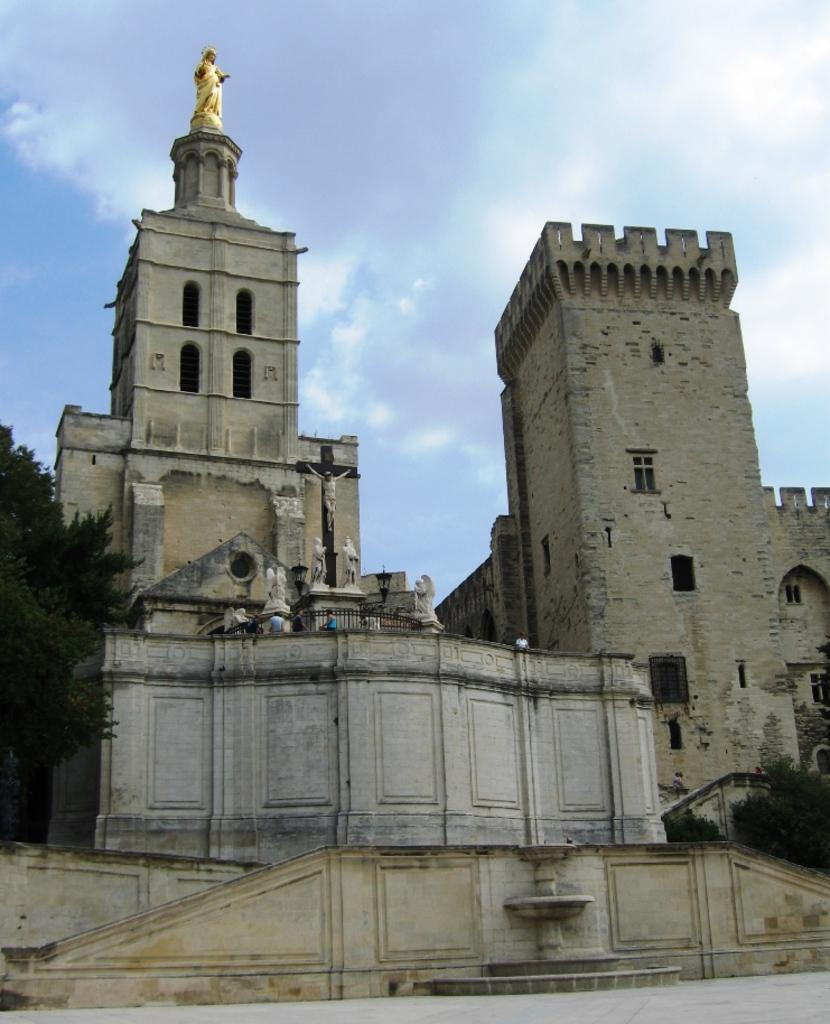What is located in the center of the image? There are buildings in the center of the image. Are there any specific features on the buildings? Yes, there is a statue on one of the buildings. What can be seen on the left side of the image? There is a tree on the left side of the image. What is visible at the top of the image? The sky is visible at the top of the image. What can be observed in the sky? Clouds are present in the sky. What type of juice is being served at the statue in the image? There is no juice or serving activity present in the image; it features buildings, a statue, a tree, and clouds in the sky. How does the pollution affect the cough of the person in the image? There is no person or cough mentioned in the image; it only includes buildings, a statue, a tree, and clouds in the sky. 